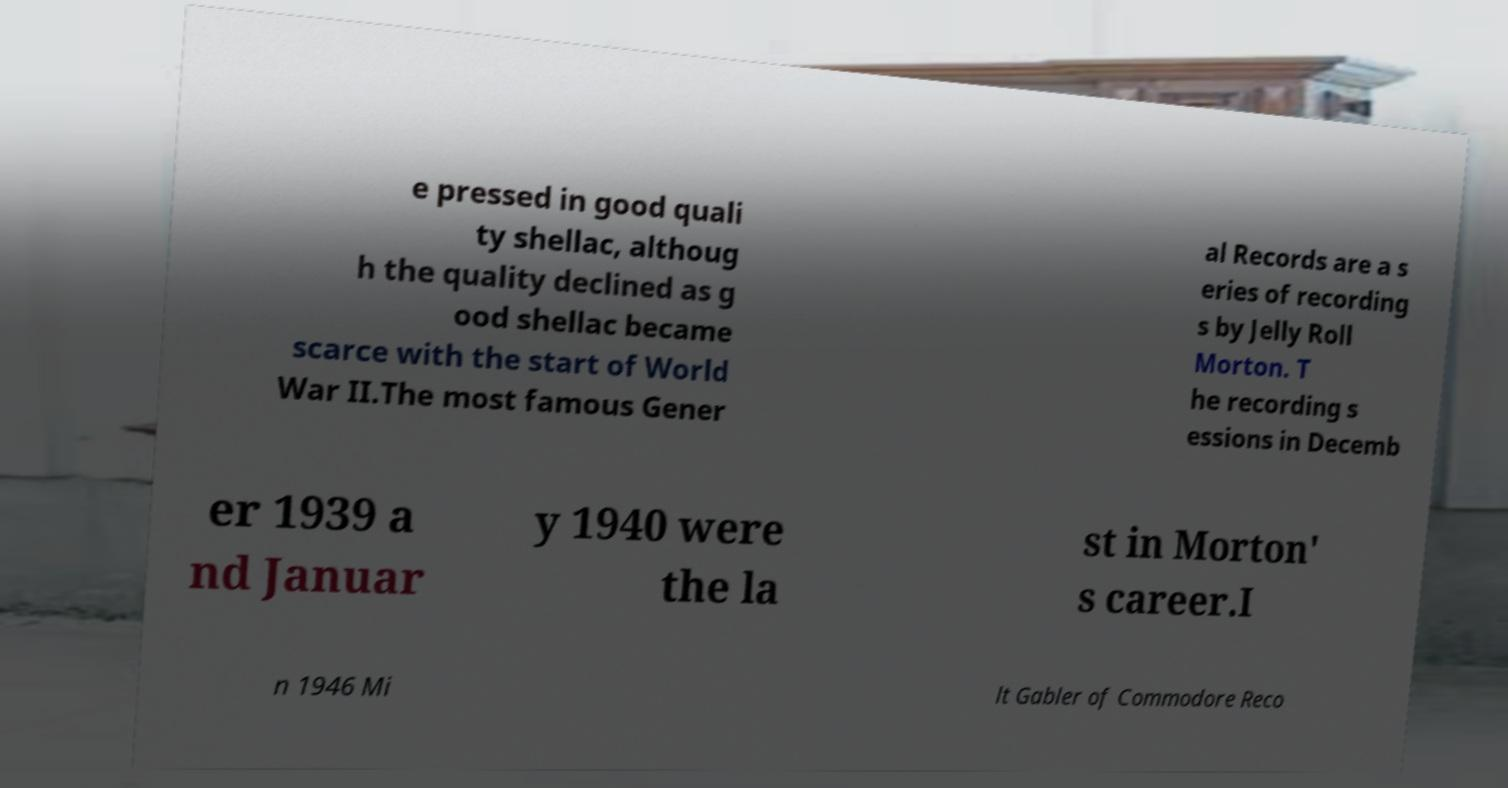Can you read and provide the text displayed in the image?This photo seems to have some interesting text. Can you extract and type it out for me? e pressed in good quali ty shellac, althoug h the quality declined as g ood shellac became scarce with the start of World War II.The most famous Gener al Records are a s eries of recording s by Jelly Roll Morton. T he recording s essions in Decemb er 1939 a nd Januar y 1940 were the la st in Morton' s career.I n 1946 Mi lt Gabler of Commodore Reco 